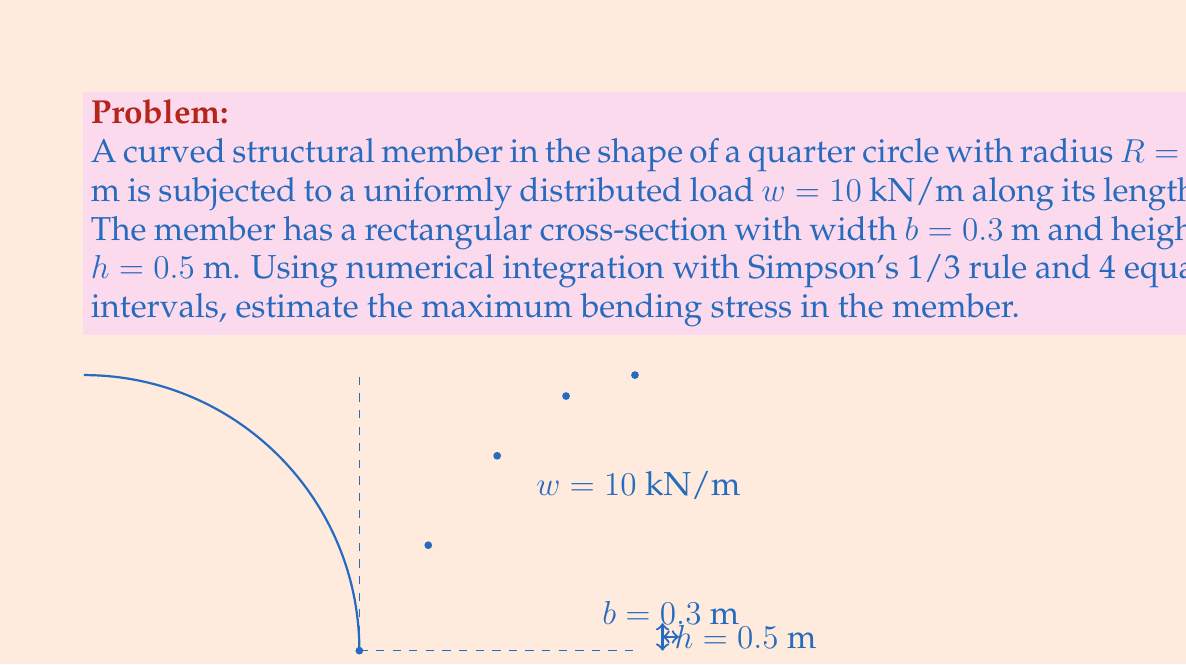What is the answer to this math problem? To estimate the maximum bending stress, we'll follow these steps:

1) The bending moment $M$ at any point along the curved member is given by:

   $$M(\theta) = wR^2(1 - \cos\theta)$$

2) The maximum bending stress occurs at the outer fiber and is given by:

   $$\sigma_{\text{max}} = \frac{My}{I}$$

   where $y = h/2 = 0.25$ m and $I = \frac{bh^3}{12} = \frac{0.3 \cdot 0.5^3}{12} = 3.125 \times 10^{-3}$ m⁴

3) To find the maximum moment, we need to integrate $M(\theta)$ over the length of the arc:

   $$M_{\text{max}} = \int_0^{\pi/2} wR^2(1 - \cos\theta) \, d\theta$$

4) Using Simpson's 1/3 rule with 4 intervals, we have:

   $$\int_0^{\pi/2} f(\theta) \, d\theta \approx \frac{\pi/2}{4 \cdot 3}[f(0) + 4f(\pi/8) + 2f(\pi/4) + 4f(3\pi/8) + f(\pi/2)]$$

5) Calculating the values:
   
   $f(0) = 0$
   $f(\pi/8) = wR^2(1 - \cos(\pi/8)) = 10 \cdot 5^2 \cdot (1 - 0.9239) = 19.0275$ kN·m
   $f(\pi/4) = wR^2(1 - \cos(\pi/4)) = 10 \cdot 5^2 \cdot (1 - 0.7071) = 73.2233$ kN·m
   $f(3\pi/8) = wR^2(1 - \cos(3\pi/8)) = 10 \cdot 5^2 \cdot (1 - 0.3827) = 154.3325$ kN·m
   $f(\pi/2) = wR^2(1 - \cos(\pi/2)) = 10 \cdot 5^2 \cdot (1 - 0) = 250$ kN·m

6) Applying Simpson's rule:

   $$M_{\text{max}} \approx \frac{\pi/2}{4 \cdot 3}[0 + 4(19.0275) + 2(73.2233) + 4(154.3325) + 250] = 196.3495 \text{ kN·m}$$

7) Now we can calculate the maximum stress:

   $$\sigma_{\text{max}} = \frac{M_{\text{max}}y}{I} = \frac{196.3495 \cdot 0.25}{3.125 \times 10^{-3}} = 15707.96 \text{ kPa} \approx 15.71 \text{ MPa}$$
Answer: $15.71$ MPa 